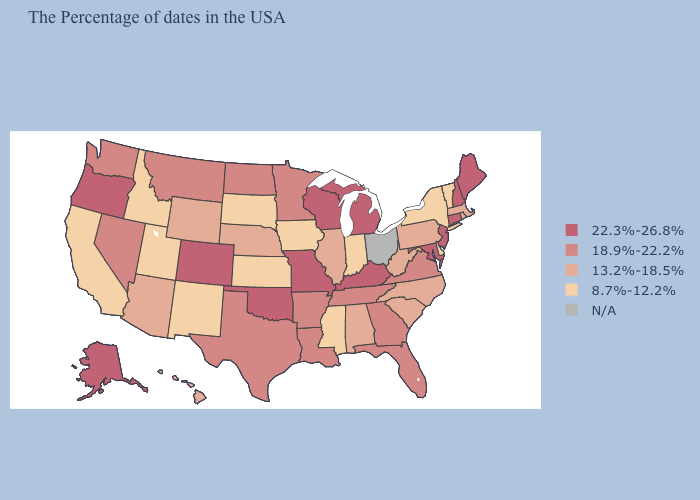Is the legend a continuous bar?
Quick response, please. No. What is the value of Maine?
Be succinct. 22.3%-26.8%. What is the value of Arizona?
Write a very short answer. 13.2%-18.5%. Does Nevada have the lowest value in the USA?
Answer briefly. No. What is the value of Connecticut?
Write a very short answer. 22.3%-26.8%. What is the value of West Virginia?
Give a very brief answer. 13.2%-18.5%. Does the map have missing data?
Keep it brief. Yes. What is the highest value in the USA?
Write a very short answer. 22.3%-26.8%. Name the states that have a value in the range 18.9%-22.2%?
Concise answer only. Virginia, Florida, Georgia, Tennessee, Louisiana, Arkansas, Minnesota, Texas, North Dakota, Montana, Nevada, Washington. Which states have the lowest value in the West?
Short answer required. New Mexico, Utah, Idaho, California. What is the value of New Hampshire?
Write a very short answer. 22.3%-26.8%. Name the states that have a value in the range N/A?
Quick response, please. Ohio. What is the lowest value in states that border Maine?
Give a very brief answer. 22.3%-26.8%. Which states have the lowest value in the West?
Keep it brief. New Mexico, Utah, Idaho, California. 